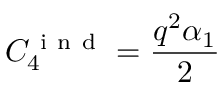Convert formula to latex. <formula><loc_0><loc_0><loc_500><loc_500>C _ { 4 } ^ { i n d } = \frac { q ^ { 2 } \alpha _ { 1 } } { 2 }</formula> 